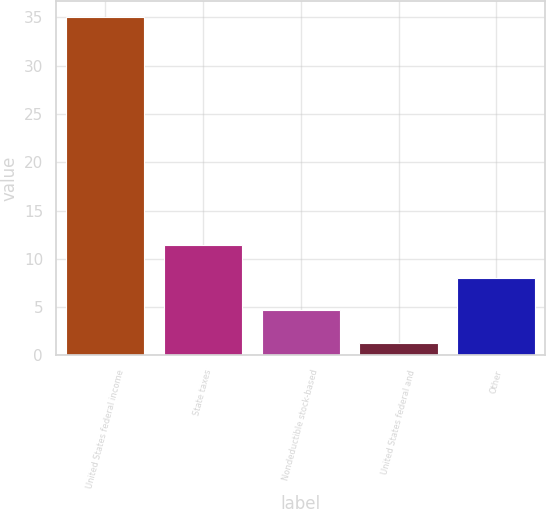Convert chart to OTSL. <chart><loc_0><loc_0><loc_500><loc_500><bar_chart><fcel>United States federal income<fcel>State taxes<fcel>Nondeductible stock-based<fcel>United States federal and<fcel>Other<nl><fcel>35<fcel>11.41<fcel>4.67<fcel>1.3<fcel>8.04<nl></chart> 